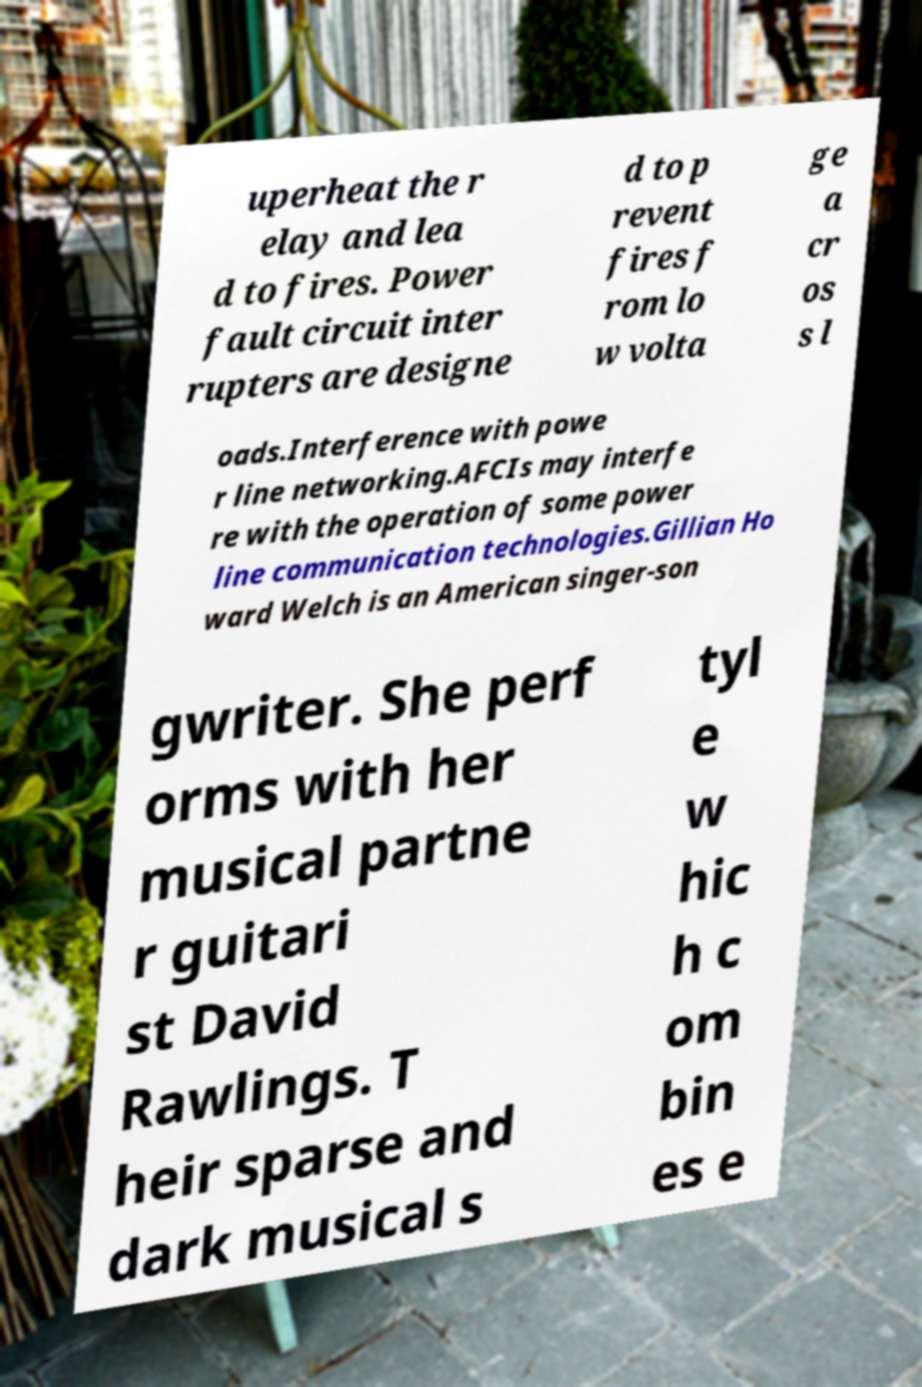There's text embedded in this image that I need extracted. Can you transcribe it verbatim? uperheat the r elay and lea d to fires. Power fault circuit inter rupters are designe d to p revent fires f rom lo w volta ge a cr os s l oads.Interference with powe r line networking.AFCIs may interfe re with the operation of some power line communication technologies.Gillian Ho ward Welch is an American singer-son gwriter. She perf orms with her musical partne r guitari st David Rawlings. T heir sparse and dark musical s tyl e w hic h c om bin es e 